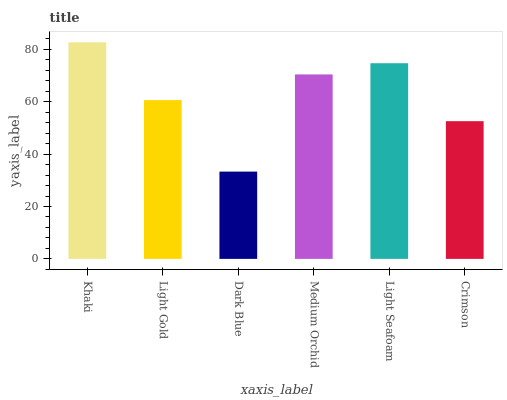Is Dark Blue the minimum?
Answer yes or no. Yes. Is Khaki the maximum?
Answer yes or no. Yes. Is Light Gold the minimum?
Answer yes or no. No. Is Light Gold the maximum?
Answer yes or no. No. Is Khaki greater than Light Gold?
Answer yes or no. Yes. Is Light Gold less than Khaki?
Answer yes or no. Yes. Is Light Gold greater than Khaki?
Answer yes or no. No. Is Khaki less than Light Gold?
Answer yes or no. No. Is Medium Orchid the high median?
Answer yes or no. Yes. Is Light Gold the low median?
Answer yes or no. Yes. Is Light Gold the high median?
Answer yes or no. No. Is Khaki the low median?
Answer yes or no. No. 